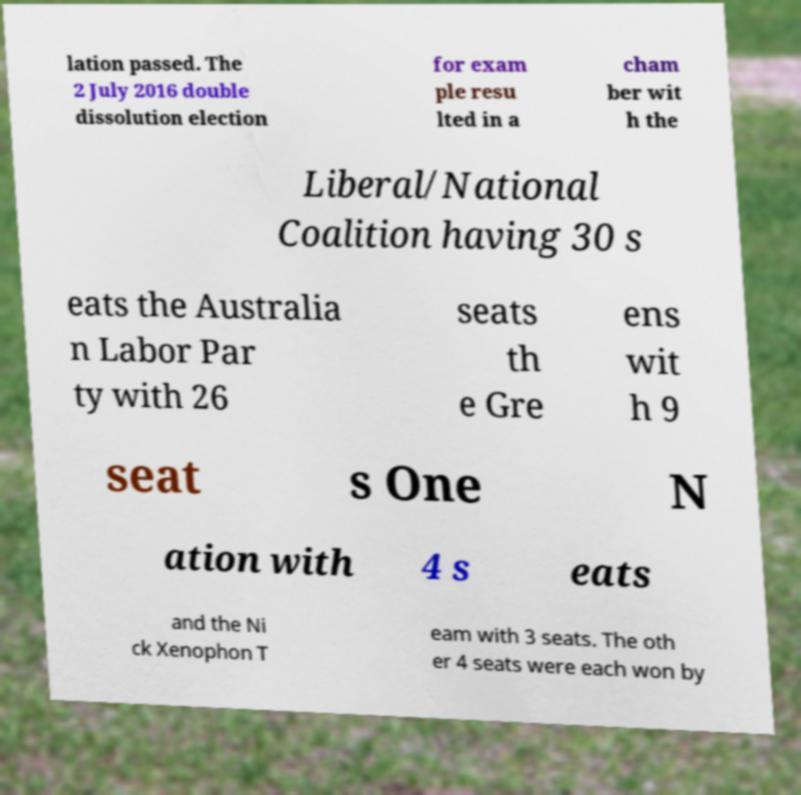Can you read and provide the text displayed in the image?This photo seems to have some interesting text. Can you extract and type it out for me? lation passed. The 2 July 2016 double dissolution election for exam ple resu lted in a cham ber wit h the Liberal/National Coalition having 30 s eats the Australia n Labor Par ty with 26 seats th e Gre ens wit h 9 seat s One N ation with 4 s eats and the Ni ck Xenophon T eam with 3 seats. The oth er 4 seats were each won by 